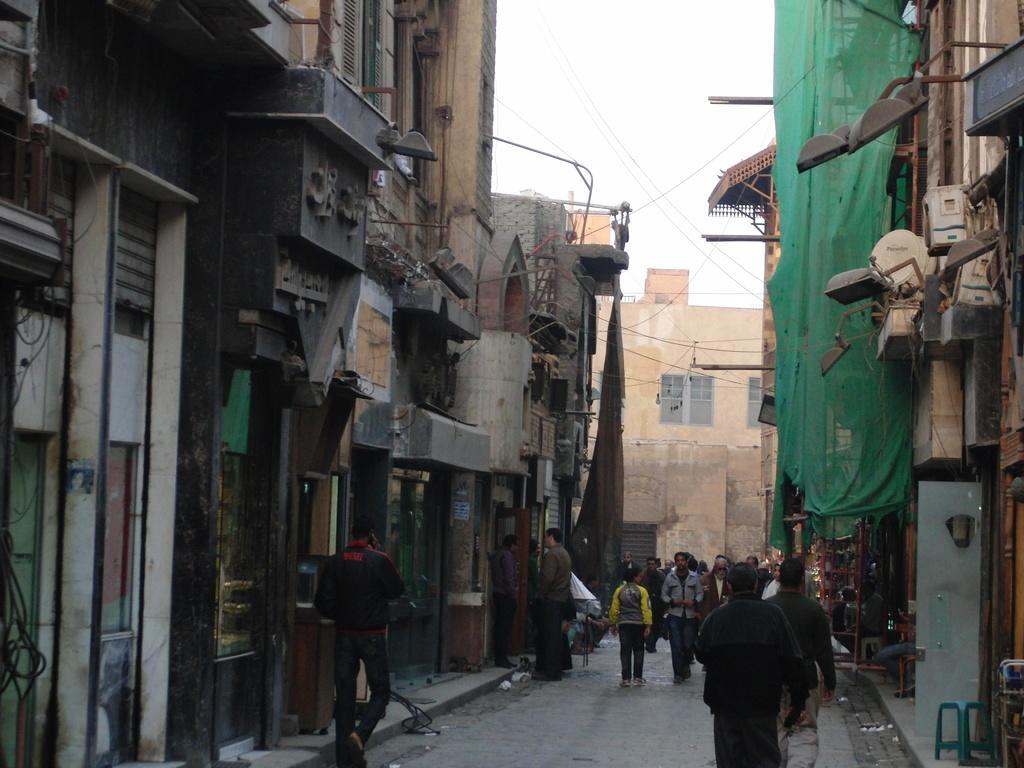How would you summarize this image in a sentence or two? This images clicked outside. There is a road in the middle on which so many people are walking. There are buildings on the right side and left side. There are there is sky on the top. 